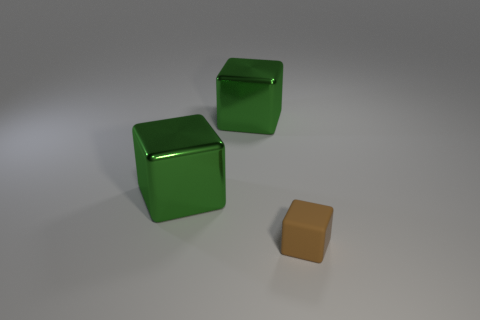Add 1 large metallic blocks. How many objects exist? 4 Subtract all brown cubes. How many cubes are left? 2 Subtract all cyan cylinders. How many green blocks are left? 2 Subtract all tiny rubber cubes. Subtract all large blue metallic balls. How many objects are left? 2 Add 1 rubber blocks. How many rubber blocks are left? 2 Add 1 brown shiny cubes. How many brown shiny cubes exist? 1 Subtract all green cubes. How many cubes are left? 1 Subtract 1 brown blocks. How many objects are left? 2 Subtract 1 blocks. How many blocks are left? 2 Subtract all gray blocks. Subtract all brown spheres. How many blocks are left? 3 